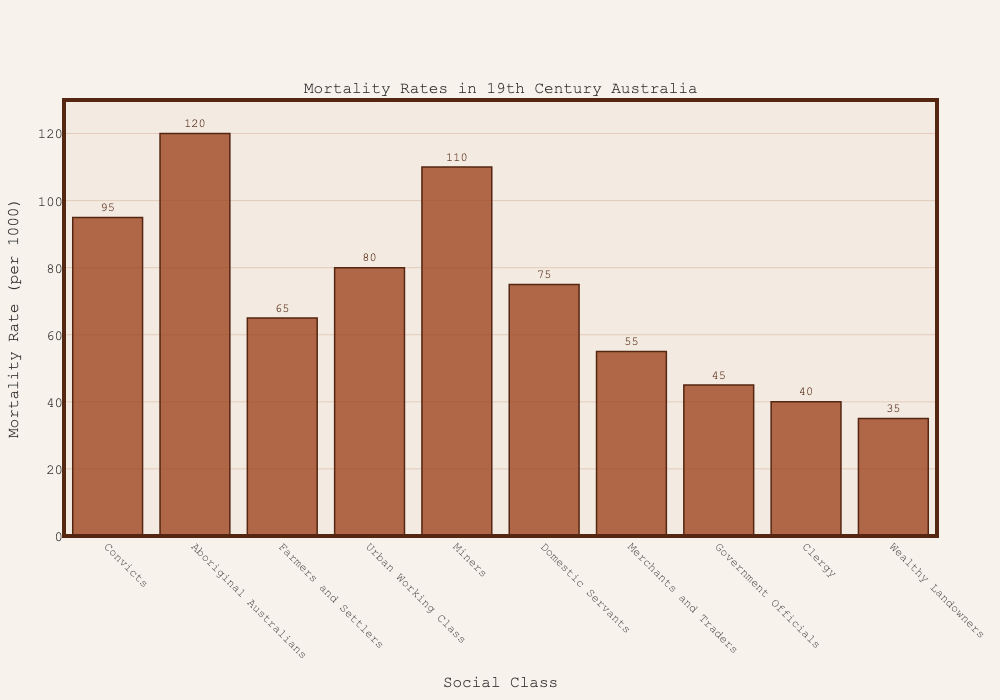What was the mortality rate for convicts? Look for the "Convicts" bar in the plot. The height of the bar and the text label show the mortality rate as 95 per 1000.
Answer: 95 Which social class had the highest mortality rate? Examine which bar reaches the highest point on the y-axis. The highest bar is for "Aboriginal Australians," indicating they had the highest mortality rate.
Answer: Aboriginal Australians Which social class had the lowest mortality rate? Identify the bar that is the shortest. The shortest bar represents the "Wealthy Landowners," indicating they had the lowest mortality rate.
Answer: Wealthy Landowners How much higher is the mortality rate for miners compared to government officials? Find the heights of the bars for "Miners" and "Government Officials." Subtract the mortality rate for Government Officials (45) from the rate for Miners (110).
Answer: 65 Which classes have a mortality rate higher than 80 per 1000? Compare each bar with the line at the 80 mark on the y-axis. The classes above this line are "Convicts," "Aboriginal Australians," "Miners," and "Urban Working Class."
Answer: Convicts, Aboriginal Australians, Miners, Urban Working Class What's the average mortality rate for farmers and settlers, domestic servants, and merchants and traders? Sum the mortality rates for Farmers and Settlers (65), Domestic Servants (75), and Merchants and Traders (55), and divide by the number of classes (3). (65 + 75 + 55) / 3 = 195 / 3 = 65
Answer: 65 How does the mortality rate of urban working class compare to that of domestic servants? Find the heights of the bars for "Urban Working Class" and "Domestic Servants." Urban Working Class has a rate of 80, and Domestic Servants have a rate of 75.
Answer: Urban Working Class has a higher mortality rate Which social class had a mortality rate of 75 per 1000? Locate the bar that reaches the position marked as 75 on the y-axis. The bar for "Domestic Servants" reaches this height.
Answer: Domestic Servants Is the mortality rate for convicts higher or lower than that for aboriginal Australians? Compare the heights of the bars for "Convicts" (95) and "Aboriginal Australians" (120). Since 95 is less than 120, it is lower.
Answer: Lower How much lower is the mortality rate for government officials compared to miners? Find the difference between mortality rates for "Miners" (110) and "Government Officials" (45). Subtract 45 from 110.
Answer: 65 